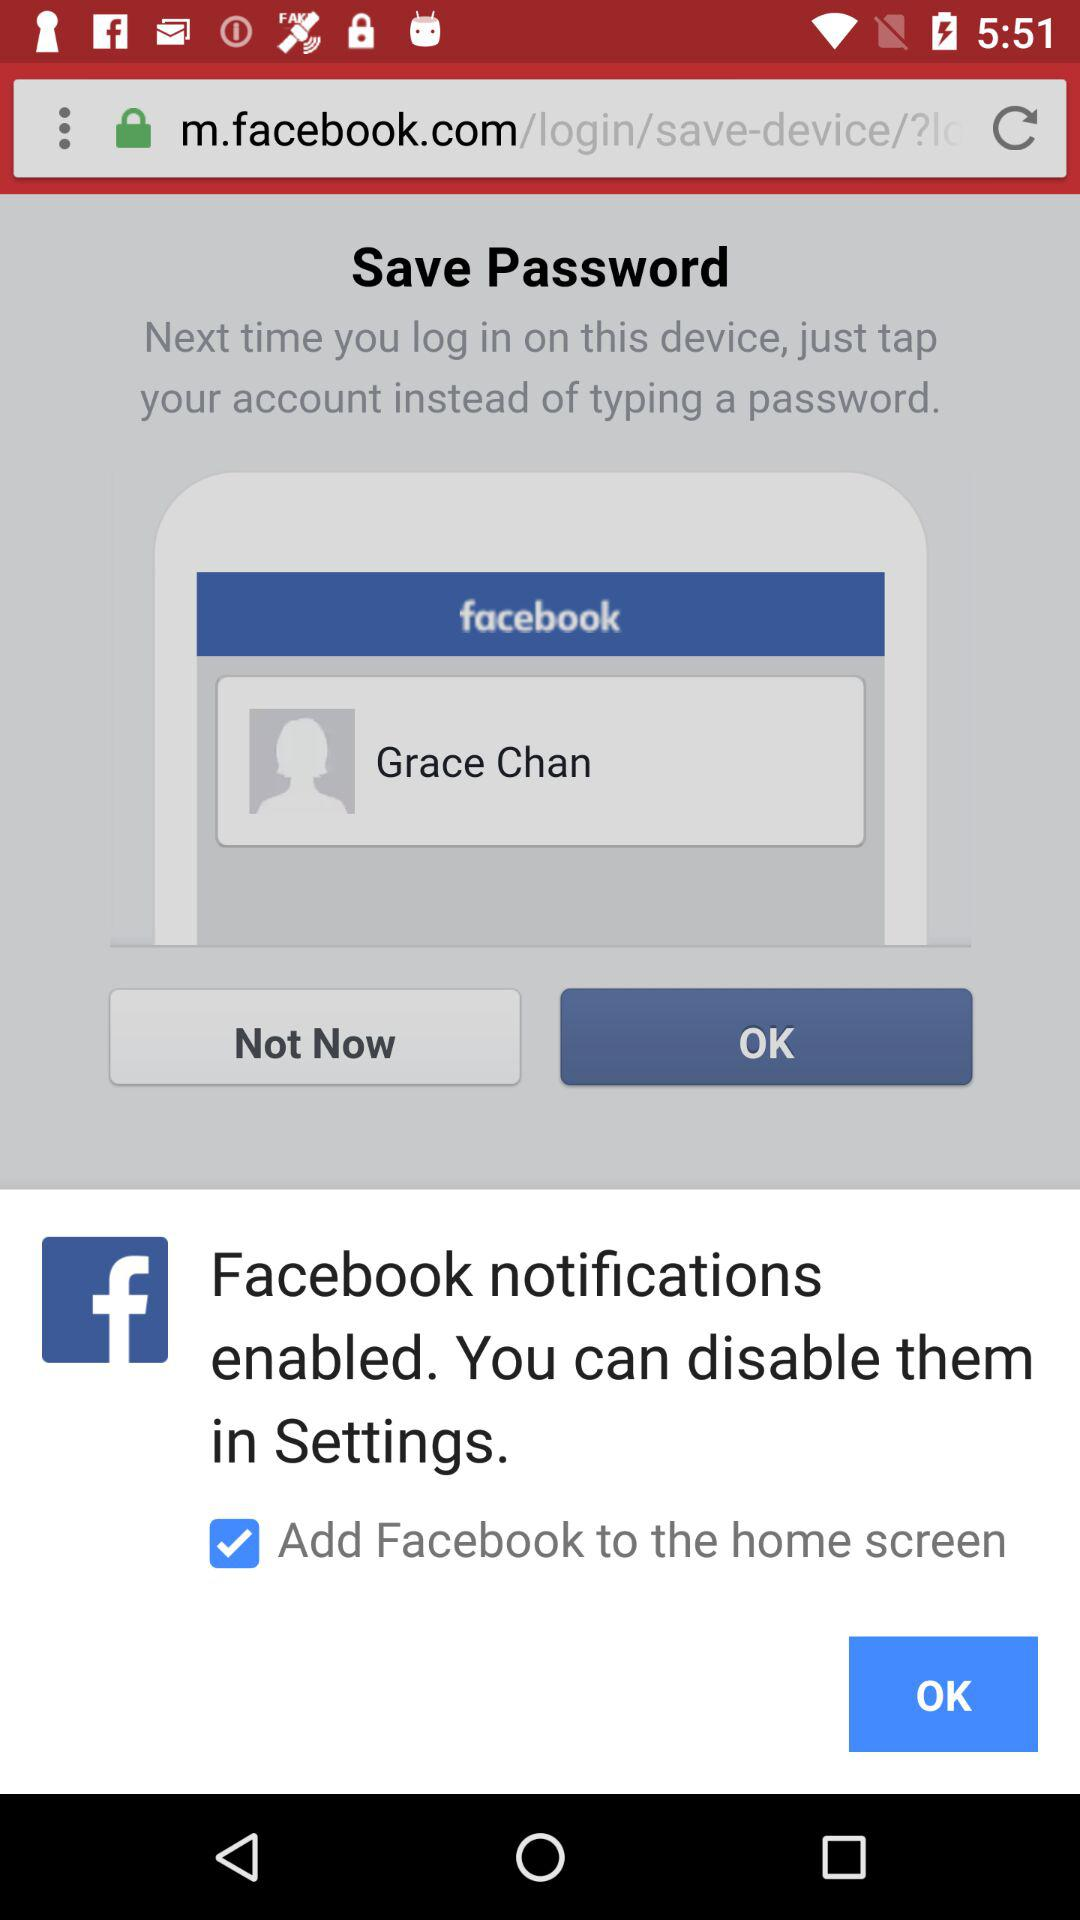What is the status of Facebook notifications? The status of Facebook notifications is enabled. 